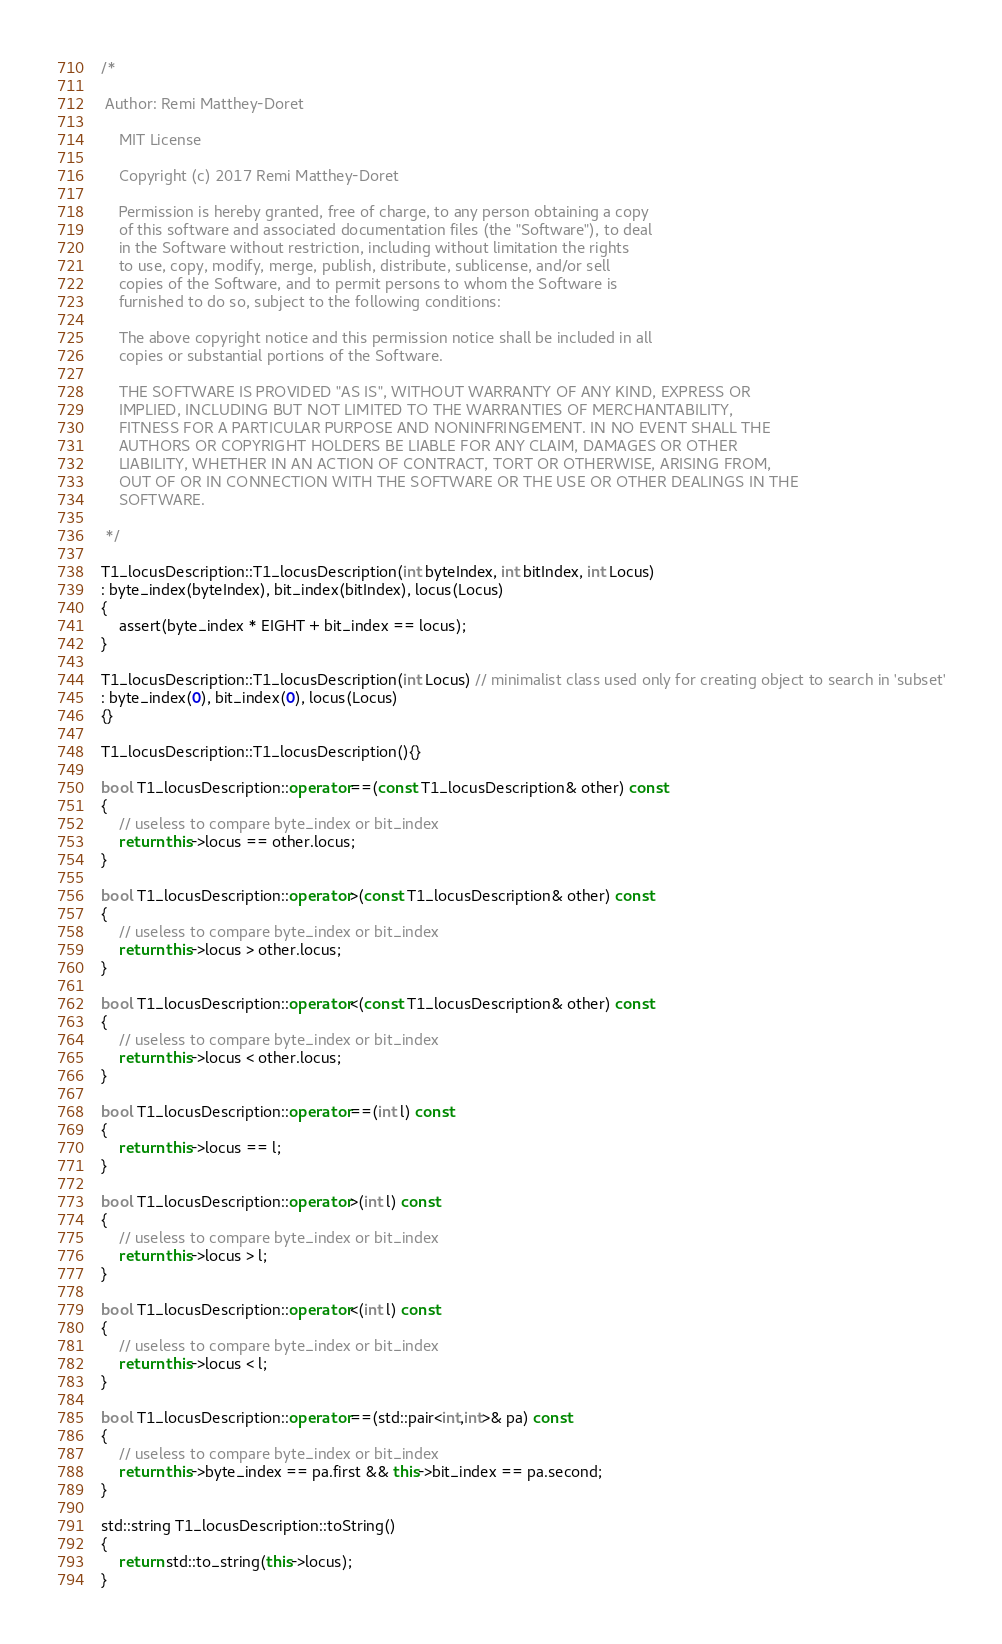<code> <loc_0><loc_0><loc_500><loc_500><_C++_>/*

 Author: Remi Matthey-Doret

    MIT License

    Copyright (c) 2017 Remi Matthey-Doret

    Permission is hereby granted, free of charge, to any person obtaining a copy
    of this software and associated documentation files (the "Software"), to deal
    in the Software without restriction, including without limitation the rights
    to use, copy, modify, merge, publish, distribute, sublicense, and/or sell
    copies of the Software, and to permit persons to whom the Software is
    furnished to do so, subject to the following conditions:

    The above copyright notice and this permission notice shall be included in all
    copies or substantial portions of the Software.

    THE SOFTWARE IS PROVIDED "AS IS", WITHOUT WARRANTY OF ANY KIND, EXPRESS OR
    IMPLIED, INCLUDING BUT NOT LIMITED TO THE WARRANTIES OF MERCHANTABILITY,
    FITNESS FOR A PARTICULAR PURPOSE AND NONINFRINGEMENT. IN NO EVENT SHALL THE
    AUTHORS OR COPYRIGHT HOLDERS BE LIABLE FOR ANY CLAIM, DAMAGES OR OTHER
    LIABILITY, WHETHER IN AN ACTION OF CONTRACT, TORT OR OTHERWISE, ARISING FROM,
    OUT OF OR IN CONNECTION WITH THE SOFTWARE OR THE USE OR OTHER DEALINGS IN THE
    SOFTWARE.

 */

T1_locusDescription::T1_locusDescription(int byteIndex, int bitIndex, int Locus)
: byte_index(byteIndex), bit_index(bitIndex), locus(Locus)
{
    assert(byte_index * EIGHT + bit_index == locus);
}

T1_locusDescription::T1_locusDescription(int Locus) // minimalist class used only for creating object to search in 'subset'
: byte_index(0), bit_index(0), locus(Locus)
{}

T1_locusDescription::T1_locusDescription(){}

bool T1_locusDescription::operator==(const T1_locusDescription& other) const
{
    // useless to compare byte_index or bit_index
    return this->locus == other.locus;
}

bool T1_locusDescription::operator>(const T1_locusDescription& other) const
{
    // useless to compare byte_index or bit_index
    return this->locus > other.locus;
}

bool T1_locusDescription::operator<(const T1_locusDescription& other) const
{
    // useless to compare byte_index or bit_index
    return this->locus < other.locus;
}

bool T1_locusDescription::operator==(int l) const
{
    return this->locus == l;
}

bool T1_locusDescription::operator>(int l) const
{
    // useless to compare byte_index or bit_index
    return this->locus > l;
}

bool T1_locusDescription::operator<(int l) const
{
    // useless to compare byte_index or bit_index
    return this->locus < l;
}

bool T1_locusDescription::operator==(std::pair<int,int>& pa) const
{
    // useless to compare byte_index or bit_index
    return this->byte_index == pa.first && this->bit_index == pa.second;
}

std::string T1_locusDescription::toString()
{
    return std::to_string(this->locus);
}
</code> 